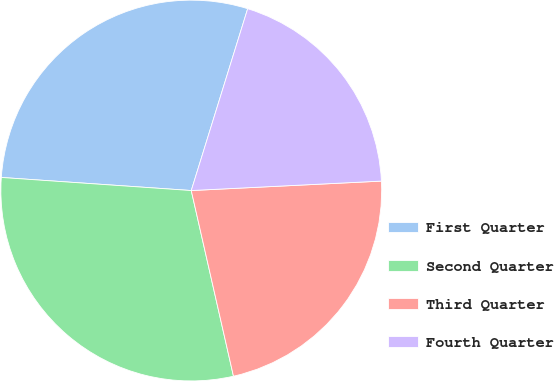Convert chart to OTSL. <chart><loc_0><loc_0><loc_500><loc_500><pie_chart><fcel>First Quarter<fcel>Second Quarter<fcel>Third Quarter<fcel>Fourth Quarter<nl><fcel>28.69%<fcel>29.65%<fcel>22.23%<fcel>19.42%<nl></chart> 